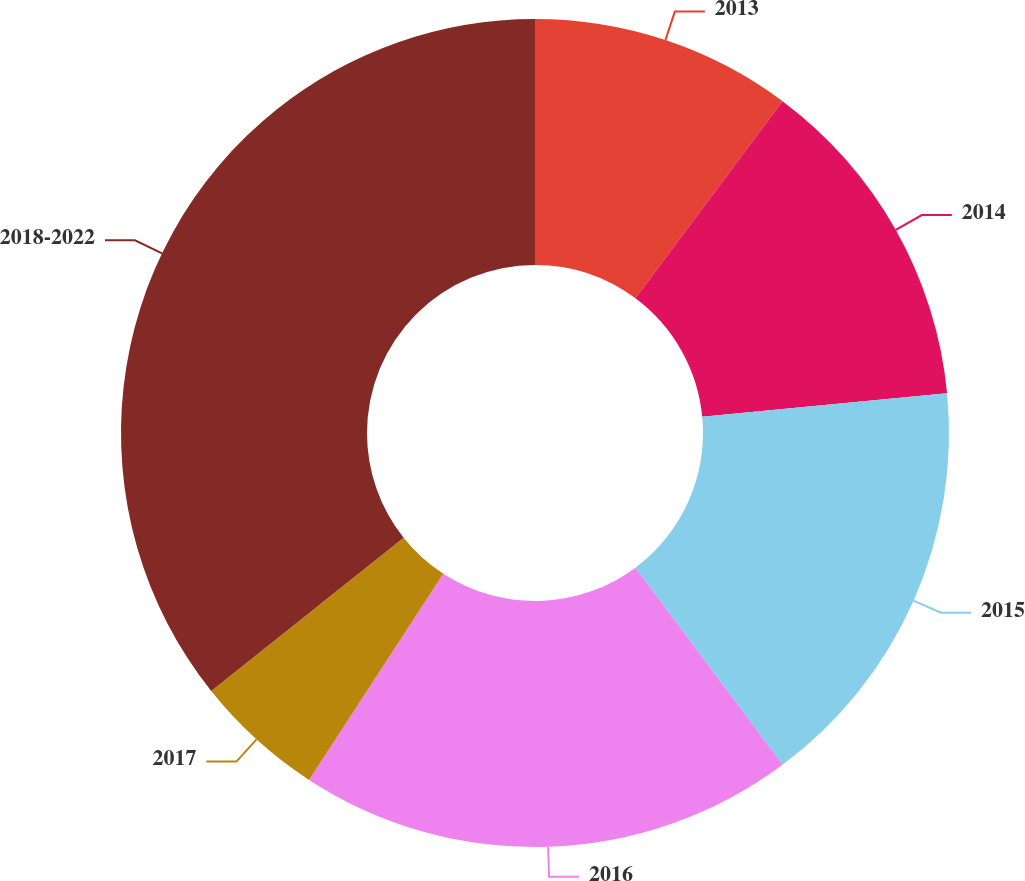Convert chart to OTSL. <chart><loc_0><loc_0><loc_500><loc_500><pie_chart><fcel>2013<fcel>2014<fcel>2015<fcel>2016<fcel>2017<fcel>2018-2022<nl><fcel>10.2%<fcel>13.27%<fcel>16.33%<fcel>19.39%<fcel>5.1%<fcel>35.71%<nl></chart> 